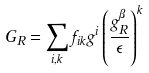Convert formula to latex. <formula><loc_0><loc_0><loc_500><loc_500>G _ { R } = \sum _ { i , k } f _ { i k } g ^ { i } \left ( \frac { g _ { R } ^ { \beta } } { \epsilon } \right ) ^ { k }</formula> 